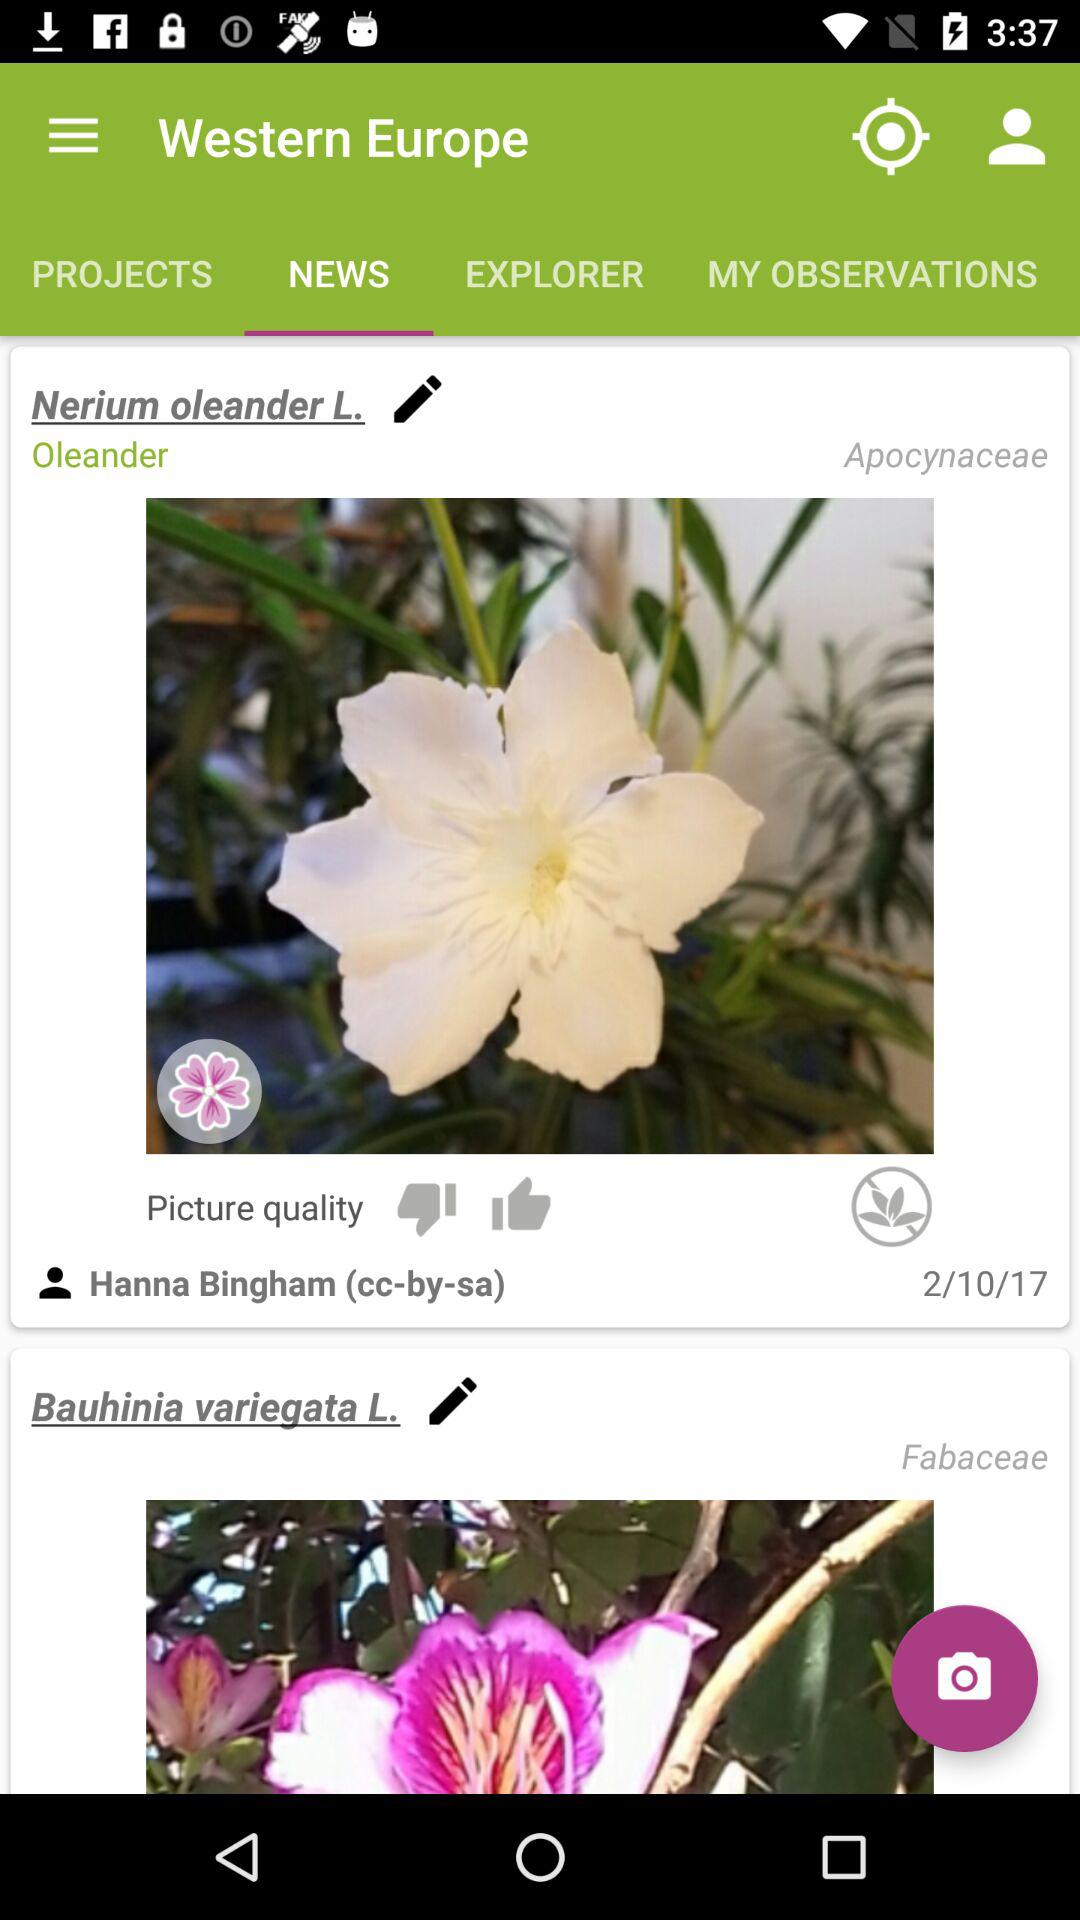Which tab is open? The opened tab is "NEWS". 